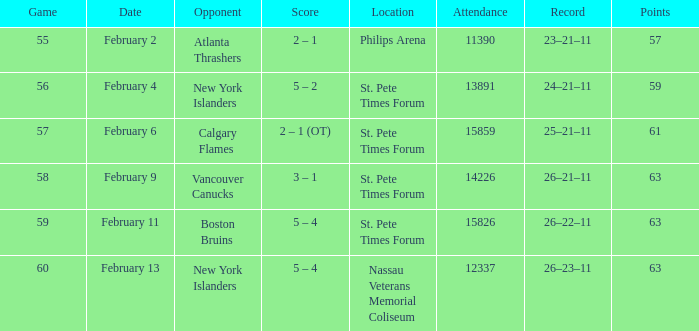What scores occurred on february 9? 3 – 1. 